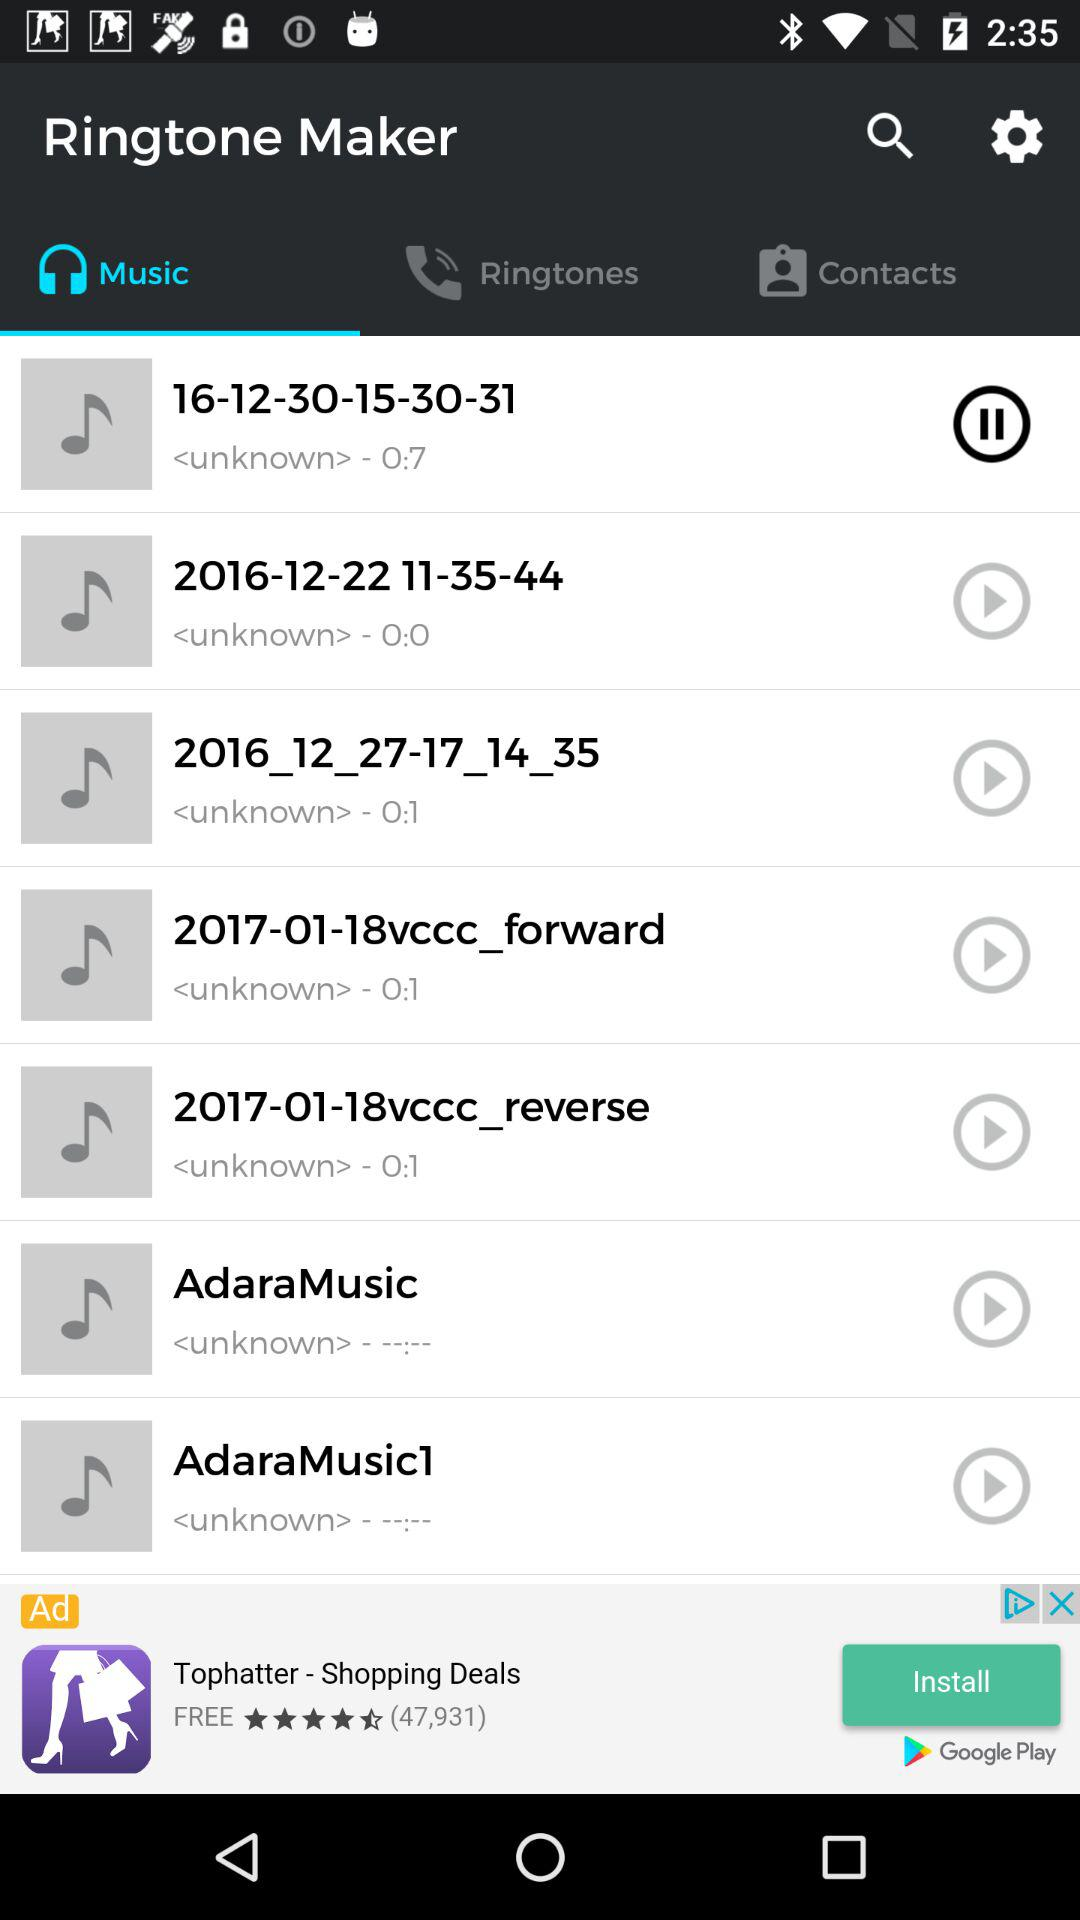Which audio is currently playing? The currently playing audio is "16-12-30-15-30-31". 